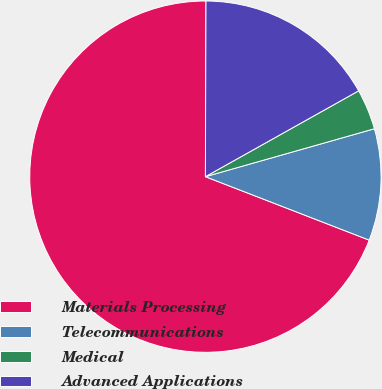Convert chart. <chart><loc_0><loc_0><loc_500><loc_500><pie_chart><fcel>Materials Processing<fcel>Telecommunications<fcel>Medical<fcel>Advanced Applications<nl><fcel>69.17%<fcel>10.28%<fcel>3.73%<fcel>16.82%<nl></chart> 